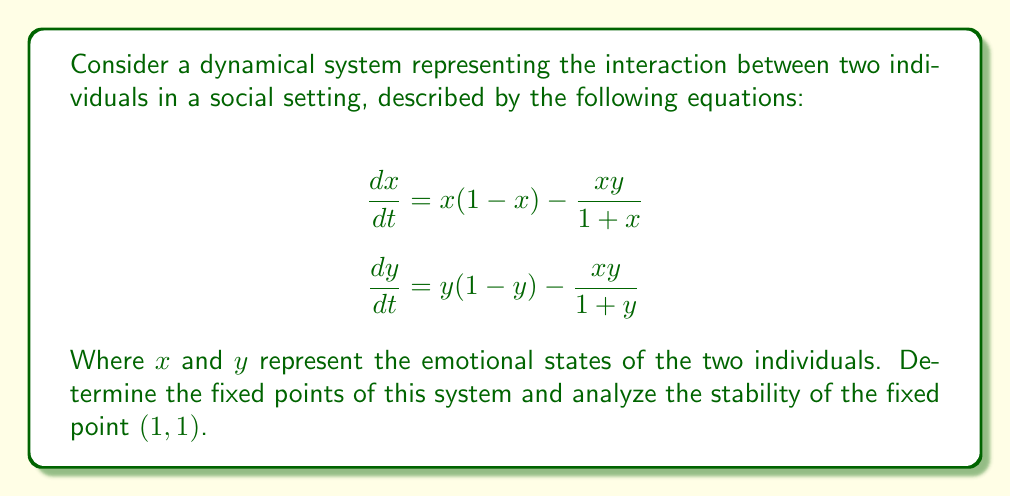Can you solve this math problem? 1. To find the fixed points, set $\frac{dx}{dt} = 0$ and $\frac{dy}{dt} = 0$:

   $$x(1-x) - \frac{xy}{1+x} = 0$$
   $$y(1-y) - \frac{xy}{1+y} = 0$$

2. Solving these equations, we find three fixed points: $(0,0)$, $(1,0)$, and $(1,1)$.

3. To analyze the stability of $(1,1)$, we need to compute the Jacobian matrix at this point:

   $$J = \begin{bmatrix}
   \frac{\partial f_1}{\partial x} & \frac{\partial f_1}{\partial y} \\
   \frac{\partial f_2}{\partial x} & \frac{\partial f_2}{\partial y}
   \end{bmatrix}$$

   Where $f_1 = x(1-x) - \frac{xy}{1+x}$ and $f_2 = y(1-y) - \frac{xy}{1+y}$

4. Computing the partial derivatives:

   $$\frac{\partial f_1}{\partial x} = 1 - 2x - \frac{y}{(1+x)^2}$$
   $$\frac{\partial f_1}{\partial y} = -\frac{x}{1+x}$$
   $$\frac{\partial f_2}{\partial x} = -\frac{y}{1+y}$$
   $$\frac{\partial f_2}{\partial y} = 1 - 2y - \frac{x}{(1+y)^2}$$

5. Evaluating the Jacobian at $(1,1)$:

   $$J_{(1,1)} = \begin{bmatrix}
   -1 - \frac{1}{4} & -\frac{1}{2} \\
   -\frac{1}{2} & -1 - \frac{1}{4}
   \end{bmatrix} = \begin{bmatrix}
   -\frac{5}{4} & -\frac{1}{2} \\
   -\frac{1}{2} & -\frac{5}{4}
   \end{bmatrix}$$

6. The eigenvalues of this matrix are:
   
   $$\lambda_1 = -\frac{7}{4}, \lambda_2 = -\frac{3}{4}$$

7. Since both eigenvalues are real and negative, the fixed point $(1,1)$ is a stable node.
Answer: Stable node 